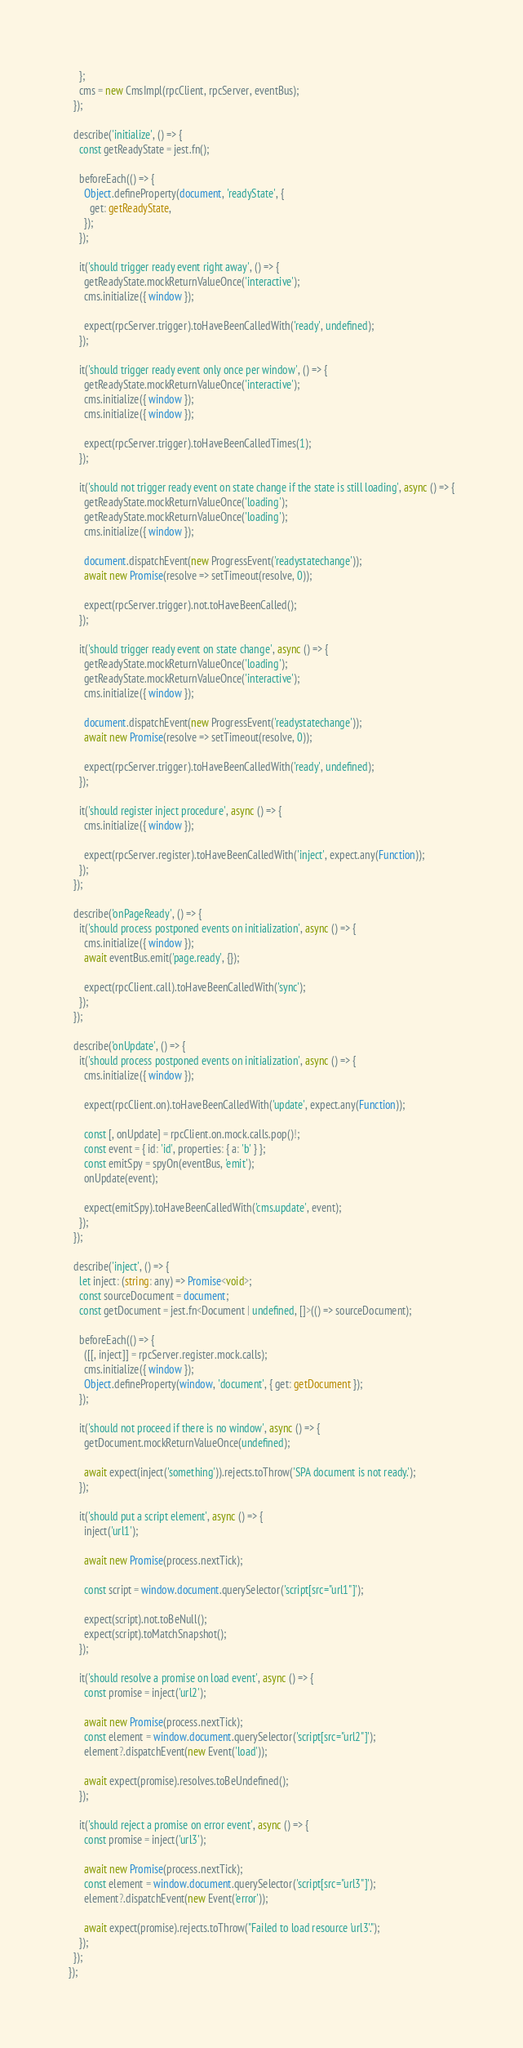Convert code to text. <code><loc_0><loc_0><loc_500><loc_500><_TypeScript_>    };
    cms = new CmsImpl(rpcClient, rpcServer, eventBus);
  });

  describe('initialize', () => {
    const getReadyState = jest.fn();

    beforeEach(() => {
      Object.defineProperty(document, 'readyState', {
        get: getReadyState,
      });
    });

    it('should trigger ready event right away', () => {
      getReadyState.mockReturnValueOnce('interactive');
      cms.initialize({ window });

      expect(rpcServer.trigger).toHaveBeenCalledWith('ready', undefined);
    });

    it('should trigger ready event only once per window', () => {
      getReadyState.mockReturnValueOnce('interactive');
      cms.initialize({ window });
      cms.initialize({ window });

      expect(rpcServer.trigger).toHaveBeenCalledTimes(1);
    });

    it('should not trigger ready event on state change if the state is still loading', async () => {
      getReadyState.mockReturnValueOnce('loading');
      getReadyState.mockReturnValueOnce('loading');
      cms.initialize({ window });

      document.dispatchEvent(new ProgressEvent('readystatechange'));
      await new Promise(resolve => setTimeout(resolve, 0));

      expect(rpcServer.trigger).not.toHaveBeenCalled();
    });

    it('should trigger ready event on state change', async () => {
      getReadyState.mockReturnValueOnce('loading');
      getReadyState.mockReturnValueOnce('interactive');
      cms.initialize({ window });

      document.dispatchEvent(new ProgressEvent('readystatechange'));
      await new Promise(resolve => setTimeout(resolve, 0));

      expect(rpcServer.trigger).toHaveBeenCalledWith('ready', undefined);
    });

    it('should register inject procedure', async () => {
      cms.initialize({ window });

      expect(rpcServer.register).toHaveBeenCalledWith('inject', expect.any(Function));
    });
  });

  describe('onPageReady', () => {
    it('should process postponed events on initialization', async () => {
      cms.initialize({ window });
      await eventBus.emit('page.ready', {});

      expect(rpcClient.call).toHaveBeenCalledWith('sync');
    });
  });

  describe('onUpdate', () => {
    it('should process postponed events on initialization', async () => {
      cms.initialize({ window });

      expect(rpcClient.on).toHaveBeenCalledWith('update', expect.any(Function));

      const [, onUpdate] = rpcClient.on.mock.calls.pop()!;
      const event = { id: 'id', properties: { a: 'b' } };
      const emitSpy = spyOn(eventBus, 'emit');
      onUpdate(event);

      expect(emitSpy).toHaveBeenCalledWith('cms.update', event);
    });
  });

  describe('inject', () => {
    let inject: (string: any) => Promise<void>;
    const sourceDocument = document;
    const getDocument = jest.fn<Document | undefined, []>(() => sourceDocument);

    beforeEach(() => {
      ([[, inject]] = rpcServer.register.mock.calls);
      cms.initialize({ window });
      Object.defineProperty(window, 'document', { get: getDocument });
    });

    it('should not proceed if there is no window', async () => {
      getDocument.mockReturnValueOnce(undefined);

      await expect(inject('something')).rejects.toThrow('SPA document is not ready.');
    });

    it('should put a script element', async () => {
      inject('url1');

      await new Promise(process.nextTick);

      const script = window.document.querySelector('script[src="url1"]');

      expect(script).not.toBeNull();
      expect(script).toMatchSnapshot();
    });

    it('should resolve a promise on load event', async () => {
      const promise = inject('url2');

      await new Promise(process.nextTick);
      const element = window.document.querySelector('script[src="url2"]');
      element?.dispatchEvent(new Event('load'));

      await expect(promise).resolves.toBeUndefined();
    });

    it('should reject a promise on error event', async () => {
      const promise = inject('url3');

      await new Promise(process.nextTick);
      const element = window.document.querySelector('script[src="url3"]');
      element?.dispatchEvent(new Event('error'));

      await expect(promise).rejects.toThrow("Failed to load resource 'url3'.");
    });
  });
});
</code> 